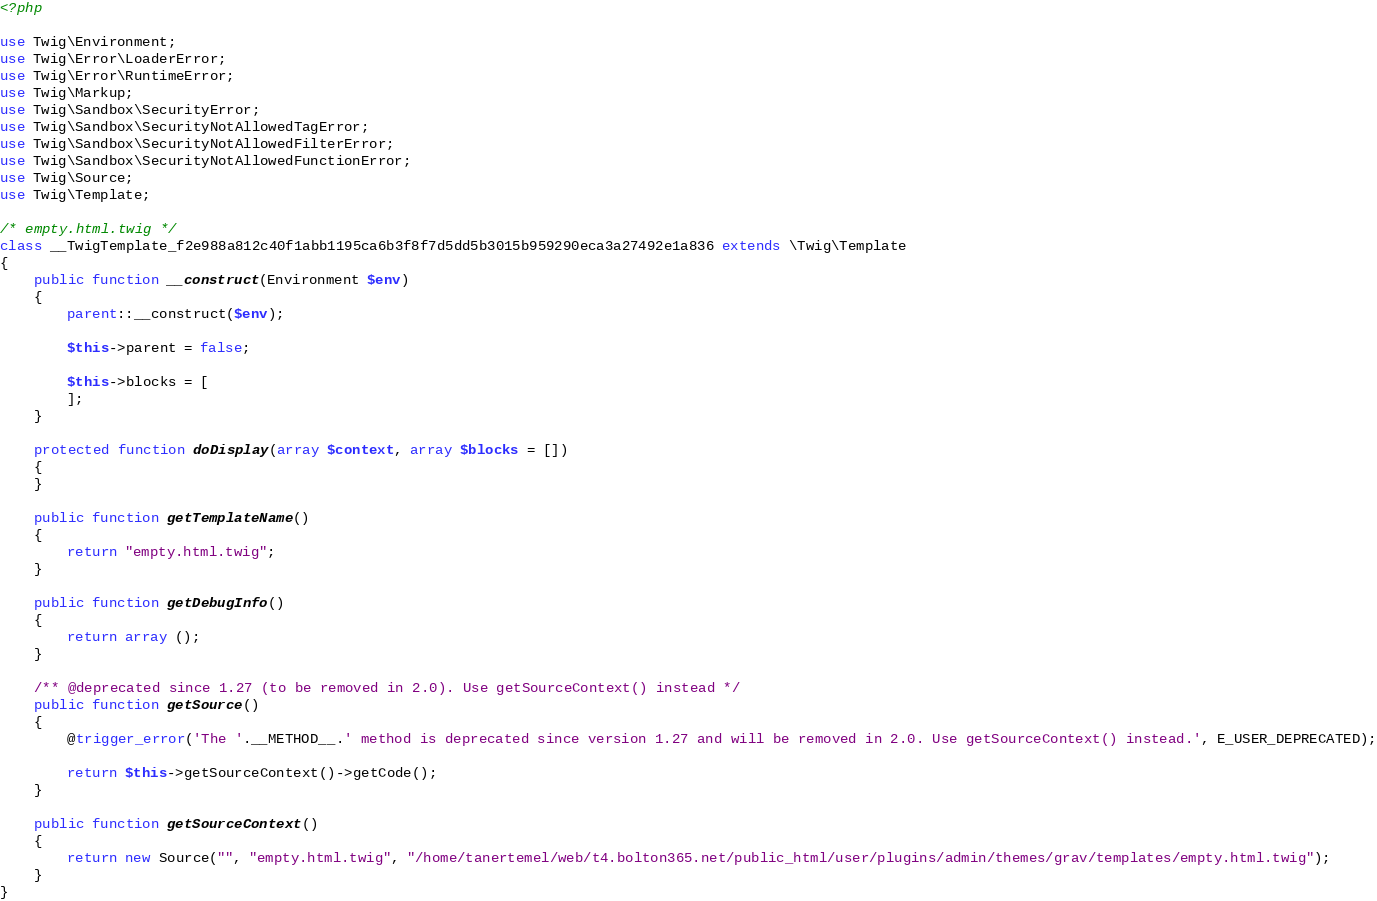<code> <loc_0><loc_0><loc_500><loc_500><_PHP_><?php

use Twig\Environment;
use Twig\Error\LoaderError;
use Twig\Error\RuntimeError;
use Twig\Markup;
use Twig\Sandbox\SecurityError;
use Twig\Sandbox\SecurityNotAllowedTagError;
use Twig\Sandbox\SecurityNotAllowedFilterError;
use Twig\Sandbox\SecurityNotAllowedFunctionError;
use Twig\Source;
use Twig\Template;

/* empty.html.twig */
class __TwigTemplate_f2e988a812c40f1abb1195ca6b3f8f7d5dd5b3015b959290eca3a27492e1a836 extends \Twig\Template
{
    public function __construct(Environment $env)
    {
        parent::__construct($env);

        $this->parent = false;

        $this->blocks = [
        ];
    }

    protected function doDisplay(array $context, array $blocks = [])
    {
    }

    public function getTemplateName()
    {
        return "empty.html.twig";
    }

    public function getDebugInfo()
    {
        return array ();
    }

    /** @deprecated since 1.27 (to be removed in 2.0). Use getSourceContext() instead */
    public function getSource()
    {
        @trigger_error('The '.__METHOD__.' method is deprecated since version 1.27 and will be removed in 2.0. Use getSourceContext() instead.', E_USER_DEPRECATED);

        return $this->getSourceContext()->getCode();
    }

    public function getSourceContext()
    {
        return new Source("", "empty.html.twig", "/home/tanertemel/web/t4.bolton365.net/public_html/user/plugins/admin/themes/grav/templates/empty.html.twig");
    }
}
</code> 